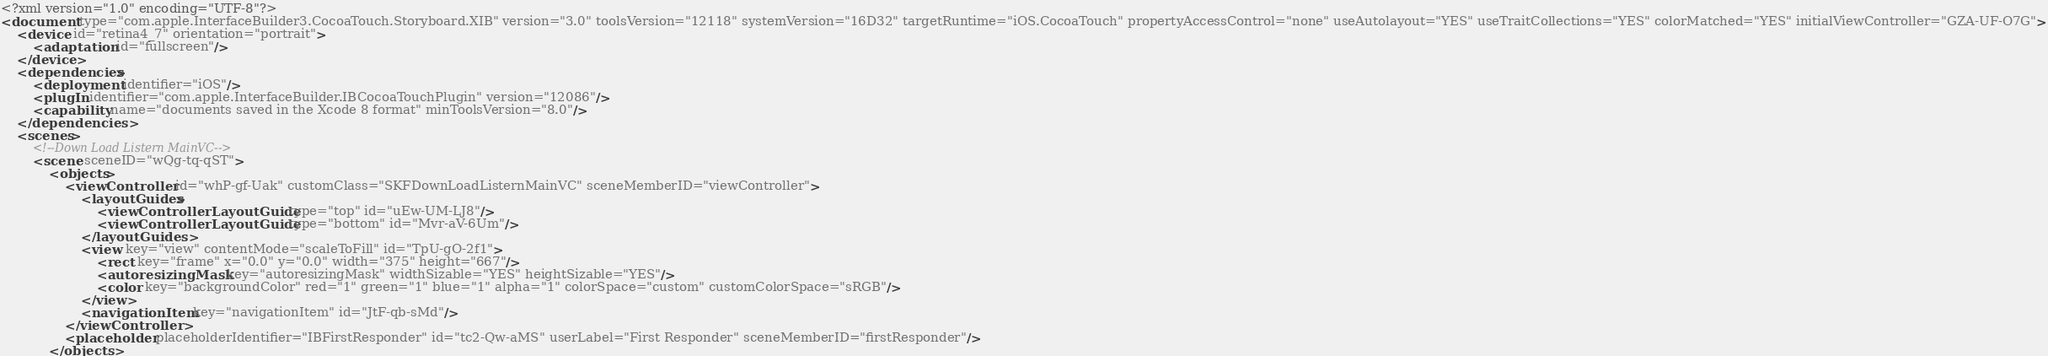<code> <loc_0><loc_0><loc_500><loc_500><_XML_><?xml version="1.0" encoding="UTF-8"?>
<document type="com.apple.InterfaceBuilder3.CocoaTouch.Storyboard.XIB" version="3.0" toolsVersion="12118" systemVersion="16D32" targetRuntime="iOS.CocoaTouch" propertyAccessControl="none" useAutolayout="YES" useTraitCollections="YES" colorMatched="YES" initialViewController="GZA-UF-O7G">
    <device id="retina4_7" orientation="portrait">
        <adaptation id="fullscreen"/>
    </device>
    <dependencies>
        <deployment identifier="iOS"/>
        <plugIn identifier="com.apple.InterfaceBuilder.IBCocoaTouchPlugin" version="12086"/>
        <capability name="documents saved in the Xcode 8 format" minToolsVersion="8.0"/>
    </dependencies>
    <scenes>
        <!--Down Load Listern MainVC-->
        <scene sceneID="wQg-tq-qST">
            <objects>
                <viewController id="whP-gf-Uak" customClass="SKFDownLoadListernMainVC" sceneMemberID="viewController">
                    <layoutGuides>
                        <viewControllerLayoutGuide type="top" id="uEw-UM-LJ8"/>
                        <viewControllerLayoutGuide type="bottom" id="Mvr-aV-6Um"/>
                    </layoutGuides>
                    <view key="view" contentMode="scaleToFill" id="TpU-gO-2f1">
                        <rect key="frame" x="0.0" y="0.0" width="375" height="667"/>
                        <autoresizingMask key="autoresizingMask" widthSizable="YES" heightSizable="YES"/>
                        <color key="backgroundColor" red="1" green="1" blue="1" alpha="1" colorSpace="custom" customColorSpace="sRGB"/>
                    </view>
                    <navigationItem key="navigationItem" id="JtF-qb-sMd"/>
                </viewController>
                <placeholder placeholderIdentifier="IBFirstResponder" id="tc2-Qw-aMS" userLabel="First Responder" sceneMemberID="firstResponder"/>
            </objects></code> 